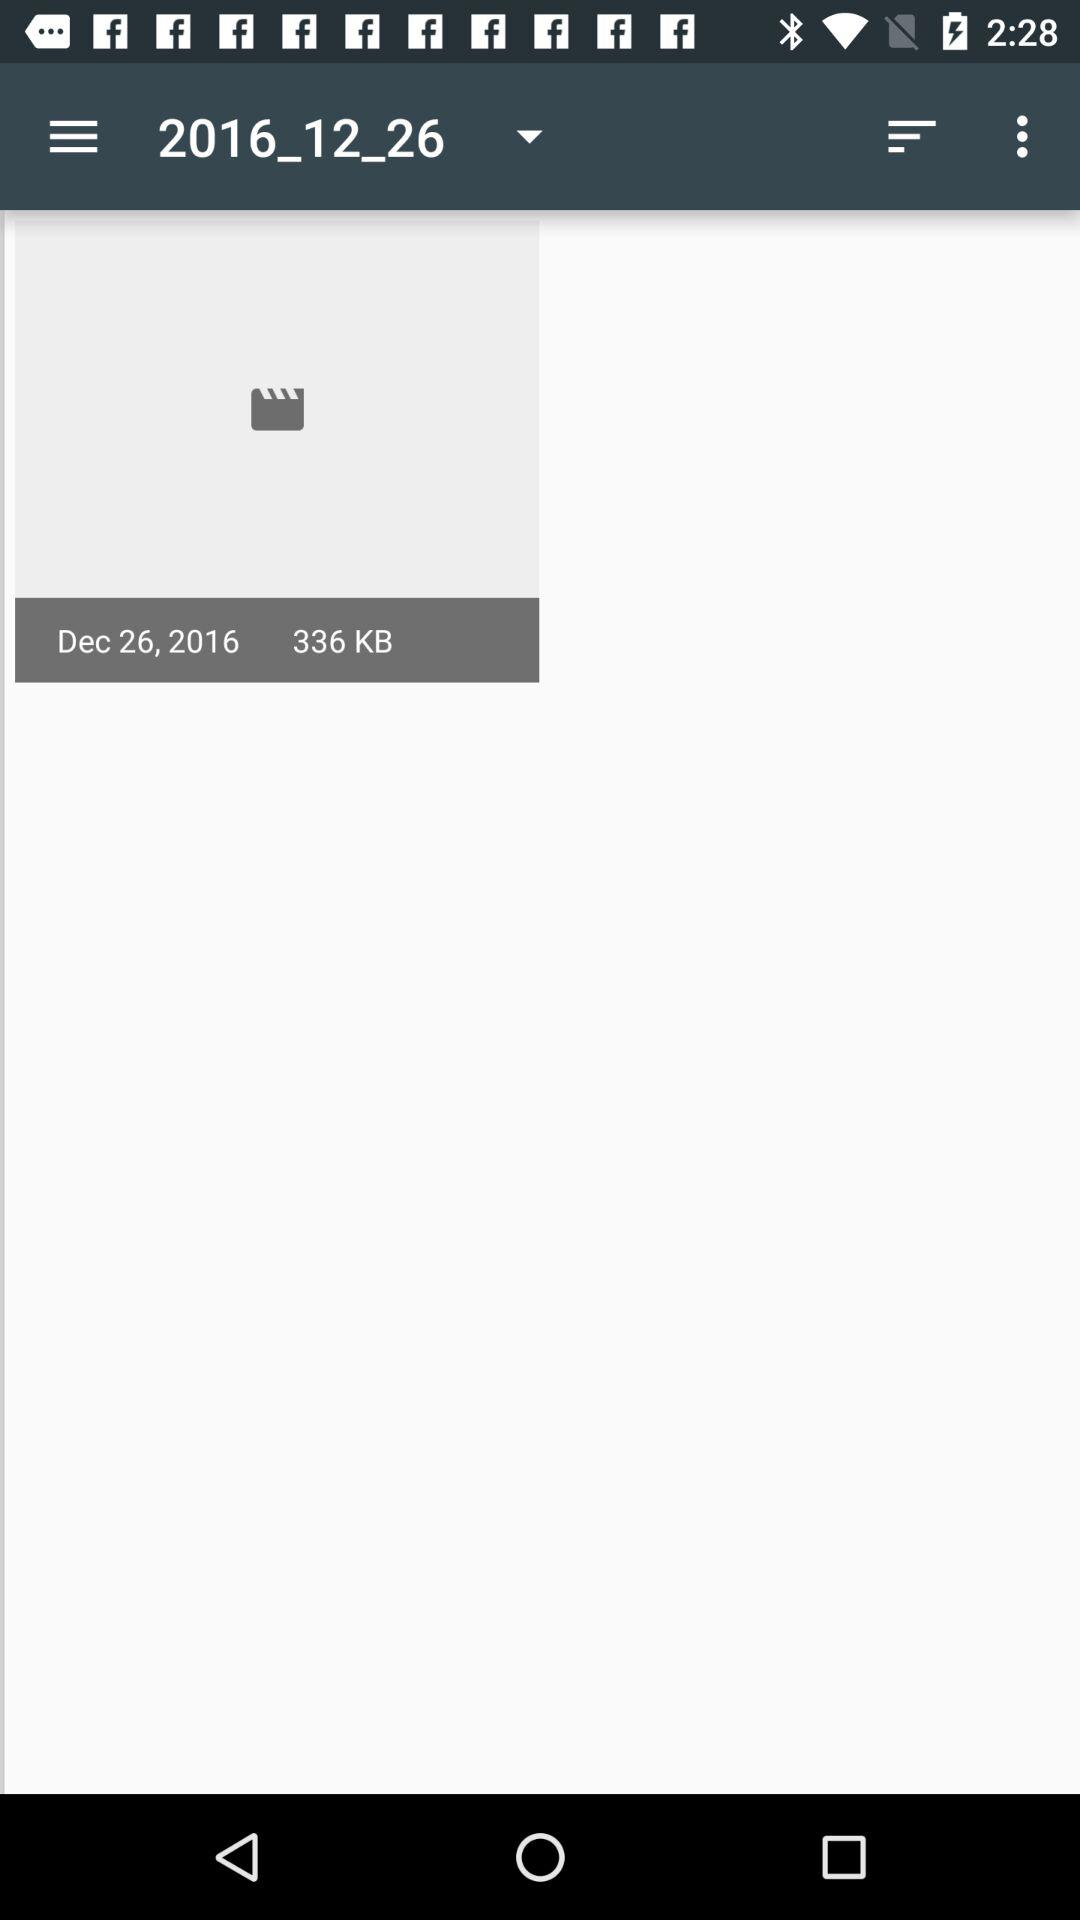What is the given memory? The given memory is 336 KB. 